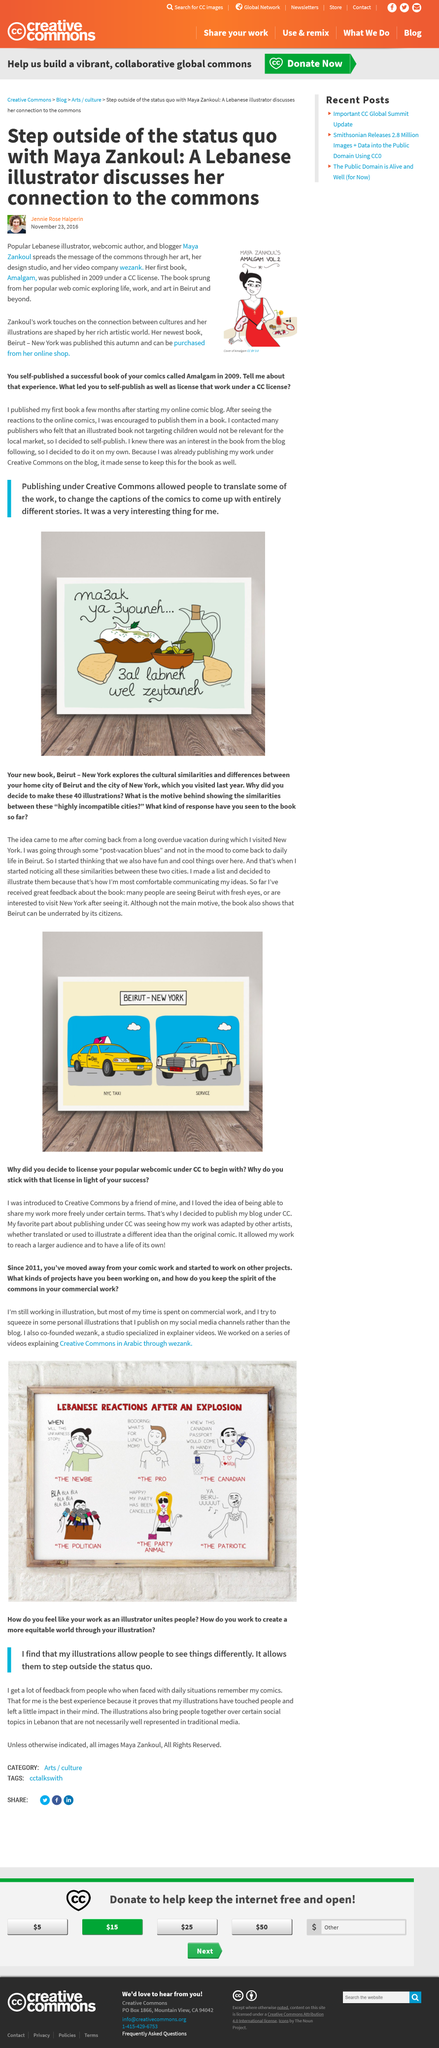List a handful of essential elements in this visual. The book "Beirut" can be acquired from the author's e-commerce platform. The illustrator publishes his personal illustrations on their social media channels. Maya Zankoul's video company is called "Wezank. Wezank is a studio that specializes in producing high-quality explainer videos for businesses and organizations. The author's two books are named 'Amalgam' and 'Beirut'. 